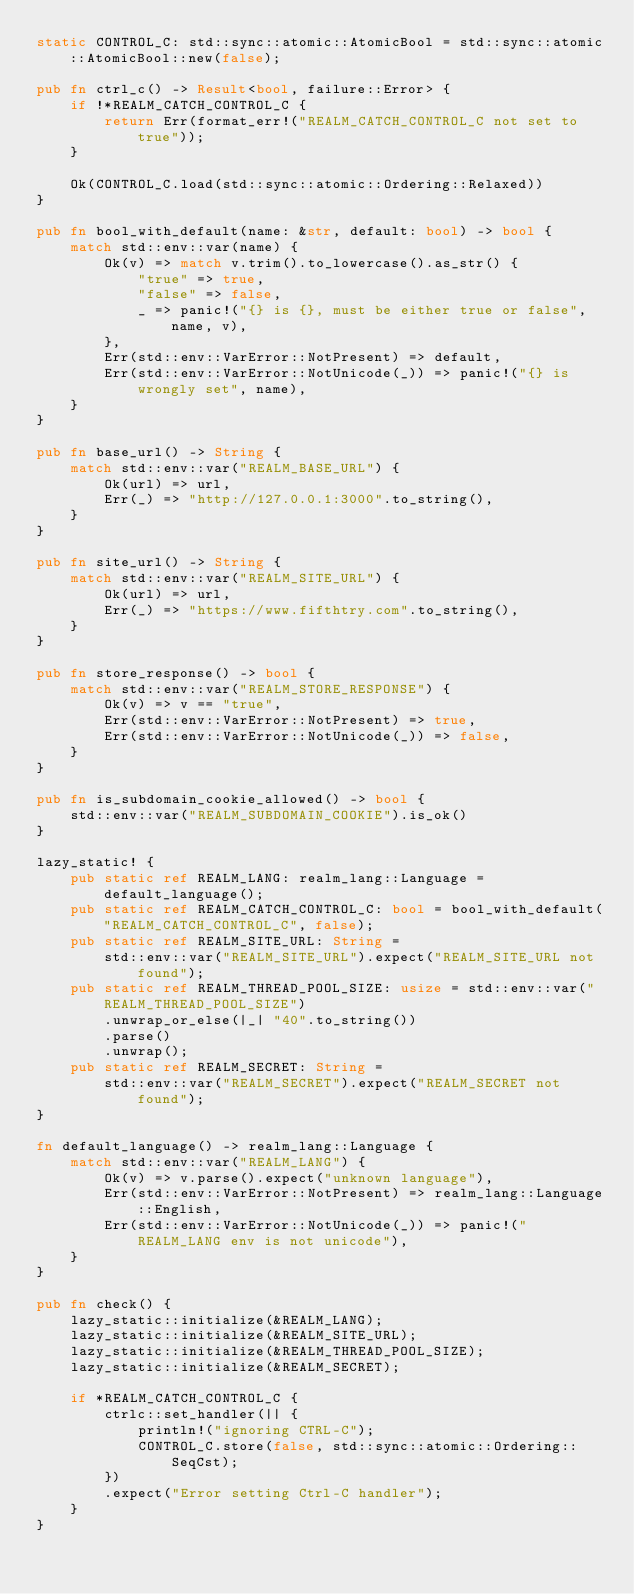Convert code to text. <code><loc_0><loc_0><loc_500><loc_500><_Rust_>static CONTROL_C: std::sync::atomic::AtomicBool = std::sync::atomic::AtomicBool::new(false);

pub fn ctrl_c() -> Result<bool, failure::Error> {
    if !*REALM_CATCH_CONTROL_C {
        return Err(format_err!("REALM_CATCH_CONTROL_C not set to true"));
    }

    Ok(CONTROL_C.load(std::sync::atomic::Ordering::Relaxed))
}

pub fn bool_with_default(name: &str, default: bool) -> bool {
    match std::env::var(name) {
        Ok(v) => match v.trim().to_lowercase().as_str() {
            "true" => true,
            "false" => false,
            _ => panic!("{} is {}, must be either true or false", name, v),
        },
        Err(std::env::VarError::NotPresent) => default,
        Err(std::env::VarError::NotUnicode(_)) => panic!("{} is wrongly set", name),
    }
}

pub fn base_url() -> String {
    match std::env::var("REALM_BASE_URL") {
        Ok(url) => url,
        Err(_) => "http://127.0.0.1:3000".to_string(),
    }
}

pub fn site_url() -> String {
    match std::env::var("REALM_SITE_URL") {
        Ok(url) => url,
        Err(_) => "https://www.fifthtry.com".to_string(),
    }
}

pub fn store_response() -> bool {
    match std::env::var("REALM_STORE_RESPONSE") {
        Ok(v) => v == "true",
        Err(std::env::VarError::NotPresent) => true,
        Err(std::env::VarError::NotUnicode(_)) => false,
    }
}

pub fn is_subdomain_cookie_allowed() -> bool {
    std::env::var("REALM_SUBDOMAIN_COOKIE").is_ok()
}

lazy_static! {
    pub static ref REALM_LANG: realm_lang::Language = default_language();
    pub static ref REALM_CATCH_CONTROL_C: bool = bool_with_default("REALM_CATCH_CONTROL_C", false);
    pub static ref REALM_SITE_URL: String =
        std::env::var("REALM_SITE_URL").expect("REALM_SITE_URL not found");
    pub static ref REALM_THREAD_POOL_SIZE: usize = std::env::var("REALM_THREAD_POOL_SIZE")
        .unwrap_or_else(|_| "40".to_string())
        .parse()
        .unwrap();
    pub static ref REALM_SECRET: String =
        std::env::var("REALM_SECRET").expect("REALM_SECRET not found");
}

fn default_language() -> realm_lang::Language {
    match std::env::var("REALM_LANG") {
        Ok(v) => v.parse().expect("unknown language"),
        Err(std::env::VarError::NotPresent) => realm_lang::Language::English,
        Err(std::env::VarError::NotUnicode(_)) => panic!("REALM_LANG env is not unicode"),
    }
}

pub fn check() {
    lazy_static::initialize(&REALM_LANG);
    lazy_static::initialize(&REALM_SITE_URL);
    lazy_static::initialize(&REALM_THREAD_POOL_SIZE);
    lazy_static::initialize(&REALM_SECRET);

    if *REALM_CATCH_CONTROL_C {
        ctrlc::set_handler(|| {
            println!("ignoring CTRL-C");
            CONTROL_C.store(false, std::sync::atomic::Ordering::SeqCst);
        })
        .expect("Error setting Ctrl-C handler");
    }
}
</code> 